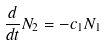<formula> <loc_0><loc_0><loc_500><loc_500>\frac { d } { d t } N _ { 2 } = - c _ { 1 } N _ { 1 }</formula> 